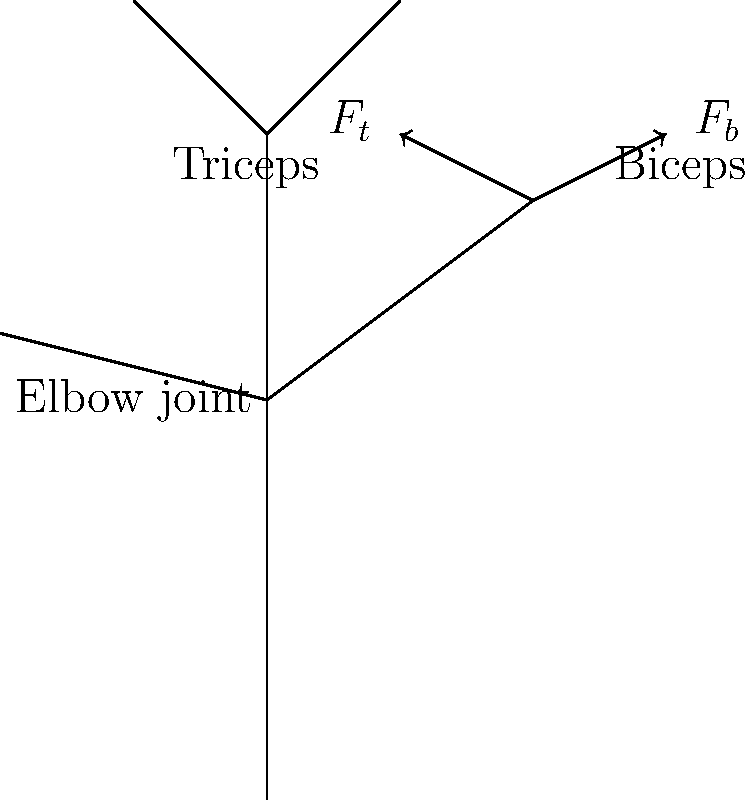In the biomechanical model of arm flexion shown above, the biceps and triceps muscles exert forces $F_b$ and $F_t$, respectively. If the moment arm of the biceps is 4 cm and that of the triceps is 2 cm, what is the net torque generated about the elbow joint when $F_b = 300$ N and $F_t = 100$ N? To solve this problem, we'll follow these steps:

1. Recall the formula for torque: $\tau = F \times r$, where $F$ is the force and $r$ is the moment arm.

2. Calculate the torque generated by the biceps:
   $\tau_b = F_b \times r_b = 300 \text{ N} \times 0.04 \text{ m} = 12 \text{ N⋅m}$

3. Calculate the torque generated by the triceps:
   $\tau_t = F_t \times r_t = 100 \text{ N} \times 0.02 \text{ m} = 2 \text{ N⋅m}$

4. Note that the triceps torque acts in the opposite direction to the biceps torque, so we subtract it.

5. Calculate the net torque:
   $\tau_{net} = \tau_b - \tau_t = 12 \text{ N⋅m} - 2 \text{ N⋅m} = 10 \text{ N⋅m}$

The net torque generated about the elbow joint is 10 N⋅m in the direction of flexion.
Answer: 10 N⋅m 